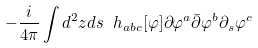Convert formula to latex. <formula><loc_0><loc_0><loc_500><loc_500>- \frac { i } { 4 \pi } \int d ^ { 2 } z d s \ h _ { a b c } [ \varphi ] \partial \varphi ^ { a } \bar { \partial } \varphi ^ { b } \partial _ { s } \varphi ^ { c }</formula> 